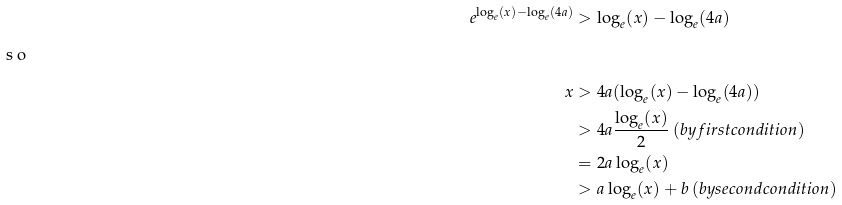<formula> <loc_0><loc_0><loc_500><loc_500>e ^ { \log _ { e } ( x ) - \log _ { e } ( 4 a ) } & > \log _ { e } ( x ) - \log _ { e } ( 4 a ) \\ \intertext { s o } x & > 4 a ( \log _ { e } ( x ) - \log _ { e } ( 4 a ) ) \\ & > 4 a \frac { \log _ { e } ( x ) } 2 \, ( b y f i r s t c o n d i t i o n ) \\ & = 2 a \log _ { e } ( x ) \\ & > a \log _ { e } ( x ) + b \, ( b y s e c o n d c o n d i t i o n )</formula> 